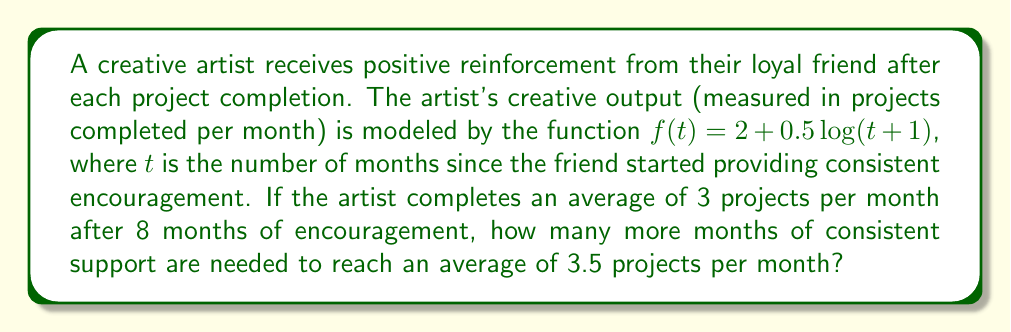Provide a solution to this math problem. Let's approach this step-by-step:

1) First, we need to verify the given information. After 8 months, the output should be 3 projects per month:

   $f(8) = 2 + 0.5\log(8+1) = 2 + 0.5\log(9) \approx 2.98$

   This is close enough to 3, considering rounding.

2) Now, we need to find $t$ such that $f(t) = 3.5$:

   $3.5 = 2 + 0.5\log(t+1)$

3) Subtract 2 from both sides:

   $1.5 = 0.5\log(t+1)$

4) Multiply both sides by 2:

   $3 = \log(t+1)$

5) Apply $e^x$ to both sides:

   $e^3 = t+1$

6) Subtract 1 from both sides:

   $e^3 - 1 = t$

7) Calculate this value:

   $t \approx 19.09$

8) Round up to the nearest month:

   $t = 20$

9) The question asks for additional months beyond the initial 8 months:

   $20 - 8 = 12$

Therefore, 12 more months of consistent support are needed.
Answer: 12 months 